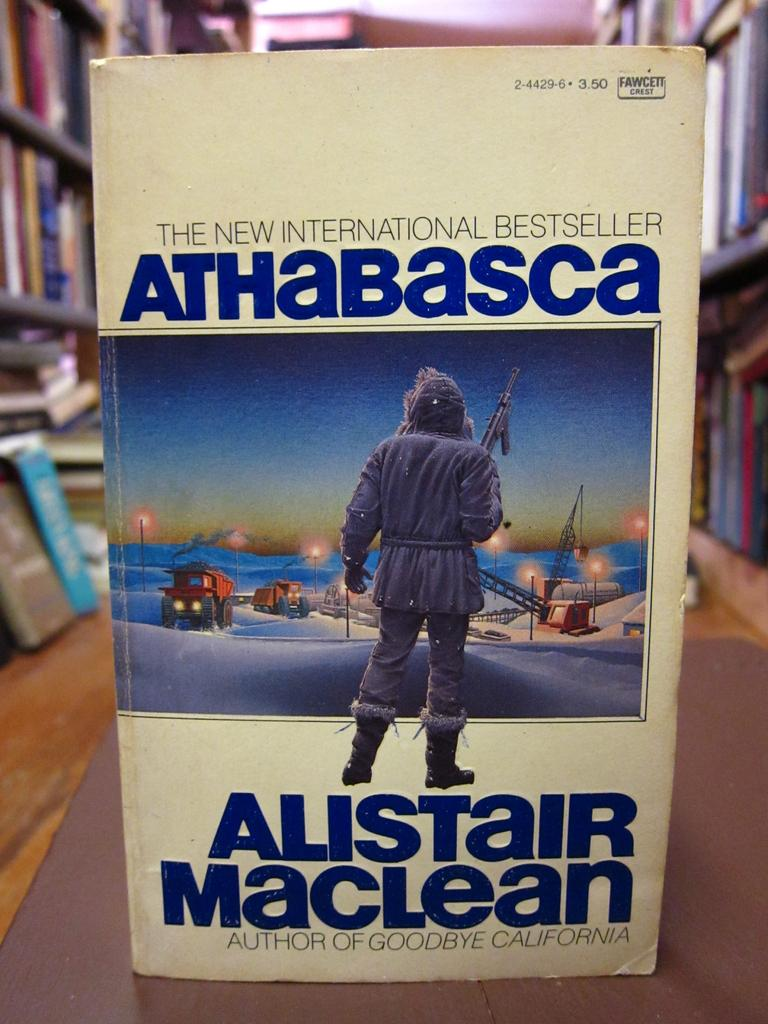<image>
Present a compact description of the photo's key features. The cover of Athabasca features a person in a winter coat and boots. 